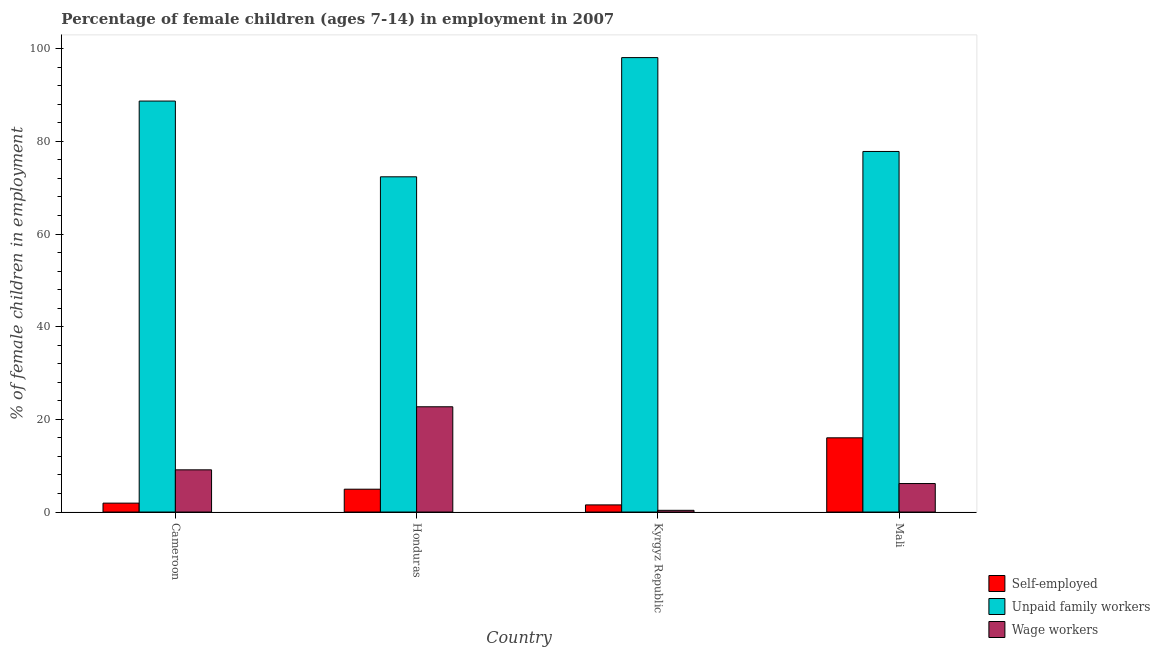How many different coloured bars are there?
Your answer should be compact. 3. How many bars are there on the 2nd tick from the right?
Provide a succinct answer. 3. What is the label of the 1st group of bars from the left?
Offer a very short reply. Cameroon. What is the percentage of children employed as unpaid family workers in Honduras?
Make the answer very short. 72.36. Across all countries, what is the maximum percentage of self employed children?
Provide a short and direct response. 16.02. Across all countries, what is the minimum percentage of self employed children?
Give a very brief answer. 1.54. In which country was the percentage of self employed children maximum?
Provide a short and direct response. Mali. In which country was the percentage of self employed children minimum?
Offer a very short reply. Kyrgyz Republic. What is the total percentage of children employed as wage workers in the graph?
Give a very brief answer. 38.35. What is the difference between the percentage of children employed as wage workers in Cameroon and that in Mali?
Make the answer very short. 2.96. What is the difference between the percentage of self employed children in Honduras and the percentage of children employed as wage workers in Kyrgyz Republic?
Make the answer very short. 4.56. What is the average percentage of children employed as unpaid family workers per country?
Provide a short and direct response. 84.25. What is the difference between the percentage of self employed children and percentage of children employed as unpaid family workers in Honduras?
Keep it short and to the point. -67.43. What is the ratio of the percentage of children employed as unpaid family workers in Kyrgyz Republic to that in Mali?
Keep it short and to the point. 1.26. Is the percentage of self employed children in Honduras less than that in Kyrgyz Republic?
Ensure brevity in your answer.  No. What is the difference between the highest and the second highest percentage of self employed children?
Make the answer very short. 11.09. What is the difference between the highest and the lowest percentage of children employed as wage workers?
Your answer should be very brief. 22.35. In how many countries, is the percentage of children employed as unpaid family workers greater than the average percentage of children employed as unpaid family workers taken over all countries?
Your answer should be compact. 2. Is the sum of the percentage of children employed as unpaid family workers in Cameroon and Kyrgyz Republic greater than the maximum percentage of children employed as wage workers across all countries?
Offer a terse response. Yes. What does the 1st bar from the left in Cameroon represents?
Keep it short and to the point. Self-employed. What does the 1st bar from the right in Honduras represents?
Give a very brief answer. Wage workers. Is it the case that in every country, the sum of the percentage of self employed children and percentage of children employed as unpaid family workers is greater than the percentage of children employed as wage workers?
Offer a terse response. Yes. Are all the bars in the graph horizontal?
Your answer should be compact. No. How many countries are there in the graph?
Give a very brief answer. 4. Does the graph contain any zero values?
Give a very brief answer. No. Where does the legend appear in the graph?
Provide a succinct answer. Bottom right. What is the title of the graph?
Make the answer very short. Percentage of female children (ages 7-14) in employment in 2007. Does "Labor Tax" appear as one of the legend labels in the graph?
Provide a succinct answer. No. What is the label or title of the X-axis?
Provide a succinct answer. Country. What is the label or title of the Y-axis?
Make the answer very short. % of female children in employment. What is the % of female children in employment in Self-employed in Cameroon?
Provide a succinct answer. 1.92. What is the % of female children in employment of Unpaid family workers in Cameroon?
Your answer should be very brief. 88.71. What is the % of female children in employment of Wage workers in Cameroon?
Give a very brief answer. 9.11. What is the % of female children in employment in Self-employed in Honduras?
Your response must be concise. 4.93. What is the % of female children in employment in Unpaid family workers in Honduras?
Give a very brief answer. 72.36. What is the % of female children in employment of Wage workers in Honduras?
Keep it short and to the point. 22.72. What is the % of female children in employment in Self-employed in Kyrgyz Republic?
Keep it short and to the point. 1.54. What is the % of female children in employment of Unpaid family workers in Kyrgyz Republic?
Offer a terse response. 98.09. What is the % of female children in employment in Wage workers in Kyrgyz Republic?
Offer a very short reply. 0.37. What is the % of female children in employment in Self-employed in Mali?
Your answer should be compact. 16.02. What is the % of female children in employment of Unpaid family workers in Mali?
Provide a short and direct response. 77.83. What is the % of female children in employment of Wage workers in Mali?
Offer a very short reply. 6.15. Across all countries, what is the maximum % of female children in employment in Self-employed?
Keep it short and to the point. 16.02. Across all countries, what is the maximum % of female children in employment of Unpaid family workers?
Provide a short and direct response. 98.09. Across all countries, what is the maximum % of female children in employment in Wage workers?
Your answer should be compact. 22.72. Across all countries, what is the minimum % of female children in employment in Self-employed?
Provide a succinct answer. 1.54. Across all countries, what is the minimum % of female children in employment of Unpaid family workers?
Make the answer very short. 72.36. Across all countries, what is the minimum % of female children in employment in Wage workers?
Offer a terse response. 0.37. What is the total % of female children in employment of Self-employed in the graph?
Offer a very short reply. 24.41. What is the total % of female children in employment in Unpaid family workers in the graph?
Offer a terse response. 336.99. What is the total % of female children in employment of Wage workers in the graph?
Offer a very short reply. 38.35. What is the difference between the % of female children in employment in Self-employed in Cameroon and that in Honduras?
Offer a terse response. -3.01. What is the difference between the % of female children in employment of Unpaid family workers in Cameroon and that in Honduras?
Give a very brief answer. 16.35. What is the difference between the % of female children in employment of Wage workers in Cameroon and that in Honduras?
Provide a succinct answer. -13.61. What is the difference between the % of female children in employment of Self-employed in Cameroon and that in Kyrgyz Republic?
Provide a succinct answer. 0.38. What is the difference between the % of female children in employment of Unpaid family workers in Cameroon and that in Kyrgyz Republic?
Offer a very short reply. -9.38. What is the difference between the % of female children in employment in Wage workers in Cameroon and that in Kyrgyz Republic?
Provide a short and direct response. 8.74. What is the difference between the % of female children in employment in Self-employed in Cameroon and that in Mali?
Ensure brevity in your answer.  -14.1. What is the difference between the % of female children in employment in Unpaid family workers in Cameroon and that in Mali?
Offer a terse response. 10.88. What is the difference between the % of female children in employment in Wage workers in Cameroon and that in Mali?
Provide a succinct answer. 2.96. What is the difference between the % of female children in employment in Self-employed in Honduras and that in Kyrgyz Republic?
Provide a short and direct response. 3.39. What is the difference between the % of female children in employment in Unpaid family workers in Honduras and that in Kyrgyz Republic?
Provide a short and direct response. -25.73. What is the difference between the % of female children in employment of Wage workers in Honduras and that in Kyrgyz Republic?
Provide a succinct answer. 22.35. What is the difference between the % of female children in employment of Self-employed in Honduras and that in Mali?
Offer a terse response. -11.09. What is the difference between the % of female children in employment of Unpaid family workers in Honduras and that in Mali?
Keep it short and to the point. -5.47. What is the difference between the % of female children in employment of Wage workers in Honduras and that in Mali?
Your response must be concise. 16.57. What is the difference between the % of female children in employment of Self-employed in Kyrgyz Republic and that in Mali?
Your response must be concise. -14.48. What is the difference between the % of female children in employment in Unpaid family workers in Kyrgyz Republic and that in Mali?
Keep it short and to the point. 20.26. What is the difference between the % of female children in employment in Wage workers in Kyrgyz Republic and that in Mali?
Provide a short and direct response. -5.78. What is the difference between the % of female children in employment of Self-employed in Cameroon and the % of female children in employment of Unpaid family workers in Honduras?
Offer a terse response. -70.44. What is the difference between the % of female children in employment in Self-employed in Cameroon and the % of female children in employment in Wage workers in Honduras?
Offer a very short reply. -20.8. What is the difference between the % of female children in employment of Unpaid family workers in Cameroon and the % of female children in employment of Wage workers in Honduras?
Keep it short and to the point. 65.99. What is the difference between the % of female children in employment in Self-employed in Cameroon and the % of female children in employment in Unpaid family workers in Kyrgyz Republic?
Offer a very short reply. -96.17. What is the difference between the % of female children in employment in Self-employed in Cameroon and the % of female children in employment in Wage workers in Kyrgyz Republic?
Give a very brief answer. 1.55. What is the difference between the % of female children in employment in Unpaid family workers in Cameroon and the % of female children in employment in Wage workers in Kyrgyz Republic?
Ensure brevity in your answer.  88.34. What is the difference between the % of female children in employment in Self-employed in Cameroon and the % of female children in employment in Unpaid family workers in Mali?
Offer a terse response. -75.91. What is the difference between the % of female children in employment of Self-employed in Cameroon and the % of female children in employment of Wage workers in Mali?
Keep it short and to the point. -4.23. What is the difference between the % of female children in employment of Unpaid family workers in Cameroon and the % of female children in employment of Wage workers in Mali?
Your answer should be very brief. 82.56. What is the difference between the % of female children in employment of Self-employed in Honduras and the % of female children in employment of Unpaid family workers in Kyrgyz Republic?
Ensure brevity in your answer.  -93.16. What is the difference between the % of female children in employment in Self-employed in Honduras and the % of female children in employment in Wage workers in Kyrgyz Republic?
Your response must be concise. 4.56. What is the difference between the % of female children in employment of Unpaid family workers in Honduras and the % of female children in employment of Wage workers in Kyrgyz Republic?
Provide a succinct answer. 71.99. What is the difference between the % of female children in employment in Self-employed in Honduras and the % of female children in employment in Unpaid family workers in Mali?
Your answer should be very brief. -72.9. What is the difference between the % of female children in employment of Self-employed in Honduras and the % of female children in employment of Wage workers in Mali?
Offer a very short reply. -1.22. What is the difference between the % of female children in employment of Unpaid family workers in Honduras and the % of female children in employment of Wage workers in Mali?
Your response must be concise. 66.21. What is the difference between the % of female children in employment in Self-employed in Kyrgyz Republic and the % of female children in employment in Unpaid family workers in Mali?
Make the answer very short. -76.29. What is the difference between the % of female children in employment of Self-employed in Kyrgyz Republic and the % of female children in employment of Wage workers in Mali?
Ensure brevity in your answer.  -4.61. What is the difference between the % of female children in employment in Unpaid family workers in Kyrgyz Republic and the % of female children in employment in Wage workers in Mali?
Keep it short and to the point. 91.94. What is the average % of female children in employment of Self-employed per country?
Your answer should be very brief. 6.1. What is the average % of female children in employment of Unpaid family workers per country?
Your answer should be compact. 84.25. What is the average % of female children in employment in Wage workers per country?
Your response must be concise. 9.59. What is the difference between the % of female children in employment of Self-employed and % of female children in employment of Unpaid family workers in Cameroon?
Your answer should be compact. -86.79. What is the difference between the % of female children in employment in Self-employed and % of female children in employment in Wage workers in Cameroon?
Provide a short and direct response. -7.19. What is the difference between the % of female children in employment in Unpaid family workers and % of female children in employment in Wage workers in Cameroon?
Provide a succinct answer. 79.6. What is the difference between the % of female children in employment in Self-employed and % of female children in employment in Unpaid family workers in Honduras?
Keep it short and to the point. -67.43. What is the difference between the % of female children in employment of Self-employed and % of female children in employment of Wage workers in Honduras?
Your response must be concise. -17.79. What is the difference between the % of female children in employment of Unpaid family workers and % of female children in employment of Wage workers in Honduras?
Ensure brevity in your answer.  49.64. What is the difference between the % of female children in employment of Self-employed and % of female children in employment of Unpaid family workers in Kyrgyz Republic?
Your answer should be very brief. -96.55. What is the difference between the % of female children in employment of Self-employed and % of female children in employment of Wage workers in Kyrgyz Republic?
Provide a short and direct response. 1.17. What is the difference between the % of female children in employment in Unpaid family workers and % of female children in employment in Wage workers in Kyrgyz Republic?
Your answer should be compact. 97.72. What is the difference between the % of female children in employment of Self-employed and % of female children in employment of Unpaid family workers in Mali?
Your answer should be compact. -61.81. What is the difference between the % of female children in employment in Self-employed and % of female children in employment in Wage workers in Mali?
Offer a very short reply. 9.87. What is the difference between the % of female children in employment of Unpaid family workers and % of female children in employment of Wage workers in Mali?
Provide a succinct answer. 71.68. What is the ratio of the % of female children in employment of Self-employed in Cameroon to that in Honduras?
Give a very brief answer. 0.39. What is the ratio of the % of female children in employment in Unpaid family workers in Cameroon to that in Honduras?
Your answer should be very brief. 1.23. What is the ratio of the % of female children in employment in Wage workers in Cameroon to that in Honduras?
Give a very brief answer. 0.4. What is the ratio of the % of female children in employment of Self-employed in Cameroon to that in Kyrgyz Republic?
Provide a succinct answer. 1.25. What is the ratio of the % of female children in employment in Unpaid family workers in Cameroon to that in Kyrgyz Republic?
Your response must be concise. 0.9. What is the ratio of the % of female children in employment of Wage workers in Cameroon to that in Kyrgyz Republic?
Offer a very short reply. 24.62. What is the ratio of the % of female children in employment in Self-employed in Cameroon to that in Mali?
Give a very brief answer. 0.12. What is the ratio of the % of female children in employment of Unpaid family workers in Cameroon to that in Mali?
Your response must be concise. 1.14. What is the ratio of the % of female children in employment of Wage workers in Cameroon to that in Mali?
Provide a succinct answer. 1.48. What is the ratio of the % of female children in employment of Self-employed in Honduras to that in Kyrgyz Republic?
Ensure brevity in your answer.  3.2. What is the ratio of the % of female children in employment in Unpaid family workers in Honduras to that in Kyrgyz Republic?
Provide a succinct answer. 0.74. What is the ratio of the % of female children in employment in Wage workers in Honduras to that in Kyrgyz Republic?
Your answer should be compact. 61.41. What is the ratio of the % of female children in employment in Self-employed in Honduras to that in Mali?
Provide a succinct answer. 0.31. What is the ratio of the % of female children in employment in Unpaid family workers in Honduras to that in Mali?
Your answer should be very brief. 0.93. What is the ratio of the % of female children in employment in Wage workers in Honduras to that in Mali?
Offer a very short reply. 3.69. What is the ratio of the % of female children in employment in Self-employed in Kyrgyz Republic to that in Mali?
Your answer should be very brief. 0.1. What is the ratio of the % of female children in employment in Unpaid family workers in Kyrgyz Republic to that in Mali?
Keep it short and to the point. 1.26. What is the ratio of the % of female children in employment of Wage workers in Kyrgyz Republic to that in Mali?
Ensure brevity in your answer.  0.06. What is the difference between the highest and the second highest % of female children in employment in Self-employed?
Offer a very short reply. 11.09. What is the difference between the highest and the second highest % of female children in employment in Unpaid family workers?
Provide a succinct answer. 9.38. What is the difference between the highest and the second highest % of female children in employment in Wage workers?
Provide a succinct answer. 13.61. What is the difference between the highest and the lowest % of female children in employment of Self-employed?
Offer a very short reply. 14.48. What is the difference between the highest and the lowest % of female children in employment in Unpaid family workers?
Give a very brief answer. 25.73. What is the difference between the highest and the lowest % of female children in employment in Wage workers?
Make the answer very short. 22.35. 